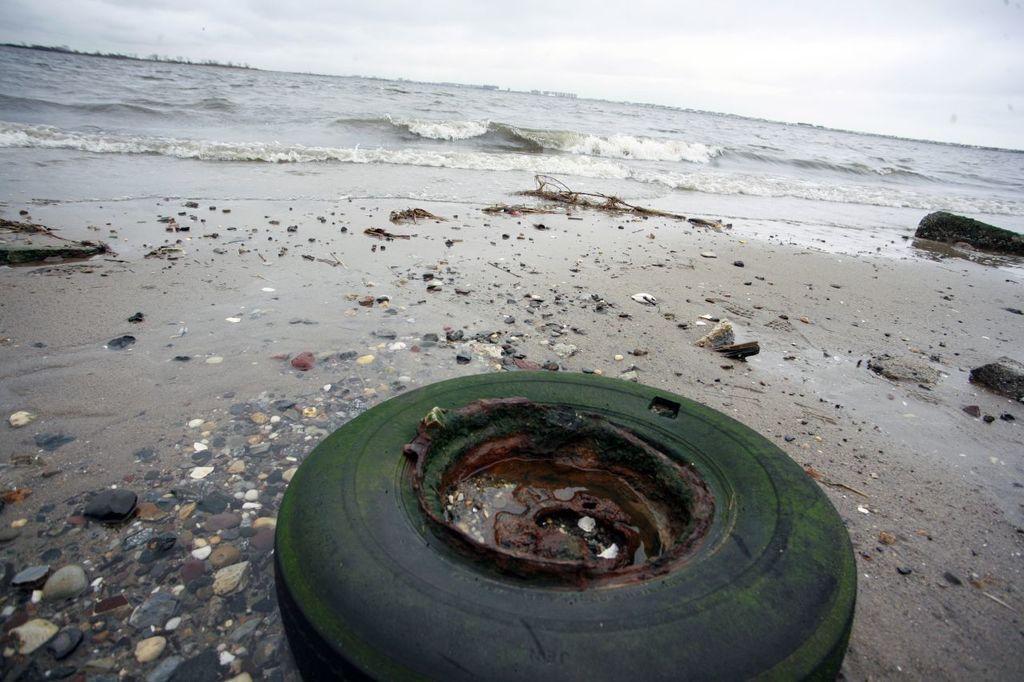In one or two sentences, can you explain what this image depicts? In this image I can see at the bottom there is the rusted iron with water. At the back side there is the sea, at the top it is the sky. 